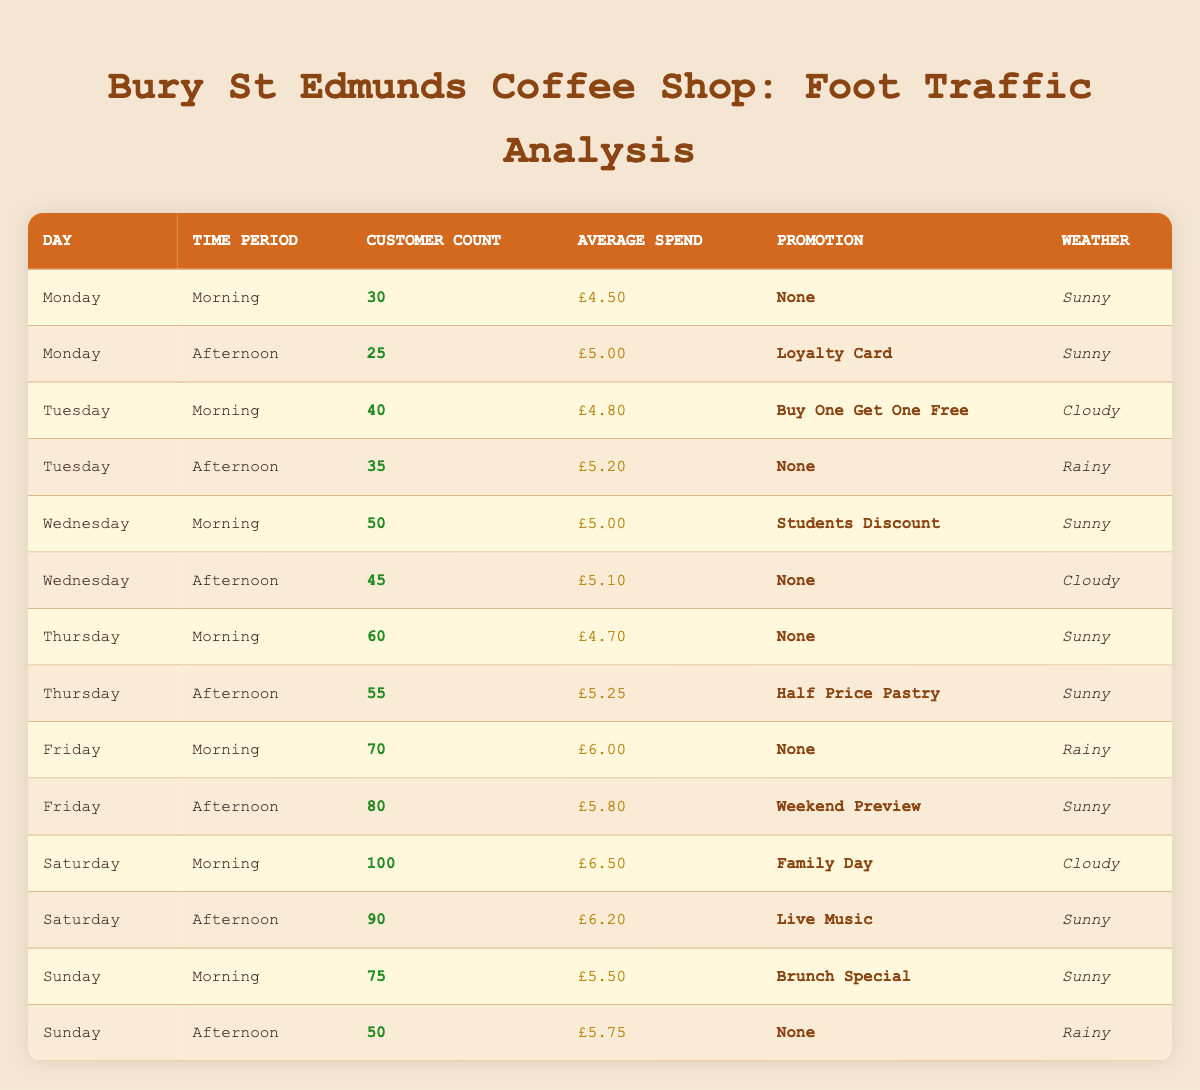What is the customer count for Saturday afternoon? In the table, I look for the row where the day is Saturday and the time period is Afternoon. In that row, the customer count is listed as 90.
Answer: 90 What was the average spend on Thursday morning? Referring to the table, I find the row for Thursday and the time period Morning. The average spend for that entry is £4.70.
Answer: £4.70 Is there a promotional offer on Tuesday morning? I check the entry for Tuesday morning in the table. The promotion listed is "Buy One Get One Free," indicating that there is indeed a promotion.
Answer: Yes Which day had the highest customer count in the morning? I review all the rows for the Morning time period and note the customer counts: Monday (30), Tuesday (40), Wednesday (50), Thursday (60), Friday (70), Saturday (100), and Sunday (75). The highest value is for Saturday, with a count of 100.
Answer: Saturday What is the total average spend for the Friday entries combined? I check both entries for Friday: Morning has an average spend of £6.00, and Afternoon has £5.80. To find the total average, I first add these amounts (6.00 + 5.80 = 11.80) and then divide by 2 to get the average (11.80 / 2 = £5.90).
Answer: £5.90 What was the weather on Wednesday afternoon? Looking up the row for Wednesday and the Afternoon time period in the table, I see that the weather condition is recorded as Cloudy.
Answer: Cloudy Did customer counts increase from Tuesday afternoon to Wednesday morning? I have the counts: Tuesday afternoon is 35, and Wednesday morning is 50. To compare, 50 (Wednesday) is greater than 35 (Tuesday), indicating an increase.
Answer: Yes What is the total customer count for the weekend (Saturday and Sunday)? I find the Saturday count is 100 (Morning) + 90 (Afternoon) = 190, and the Sunday count is 75 (Morning) + 50 (Afternoon) = 125. The total becomes 190 + 125 = 315.
Answer: 315 On which day did customers spend the most on average in the afternoon? I review the average spends for the Afternoon time period across all days: Monday £5.00, Tuesday £5.20, Wednesday £5.10, Thursday £5.25, Friday £5.80, Saturday £6.20, and Sunday £5.75. I find that Saturday has the highest spend of £6.20.
Answer: Saturday 